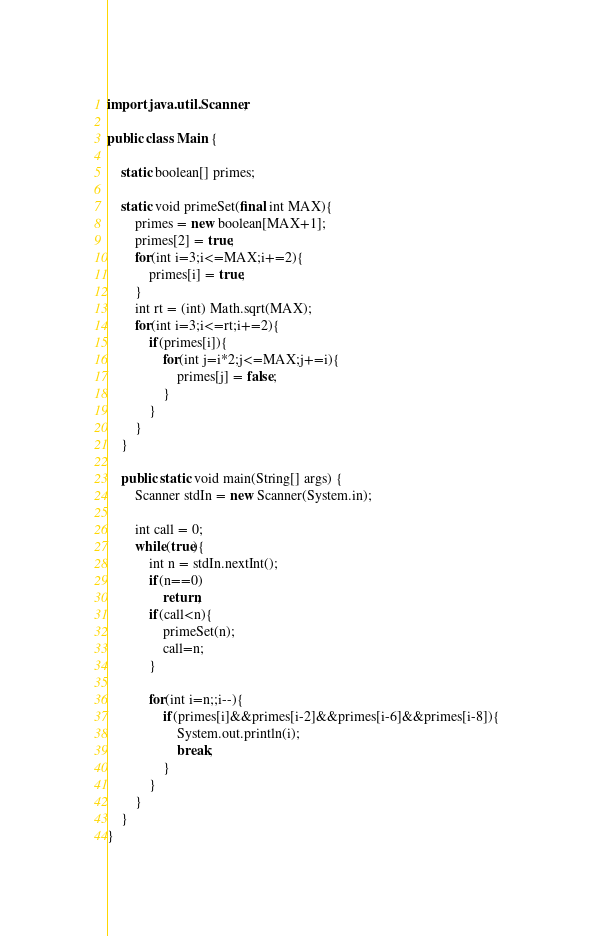<code> <loc_0><loc_0><loc_500><loc_500><_Java_>import java.util.Scanner;

public class Main {

	static boolean[] primes;

	static void primeSet(final int MAX){
		primes = new boolean[MAX+1];
		primes[2] = true;
		for(int i=3;i<=MAX;i+=2){
			primes[i] = true;
		}
		int rt = (int) Math.sqrt(MAX);
		for(int i=3;i<=rt;i+=2){
			if(primes[i]){
				for(int j=i*2;j<=MAX;j+=i){
					primes[j] = false;
				}
			}
		}
	}

	public static void main(String[] args) {
		Scanner stdIn = new Scanner(System.in);

		int call = 0;
		while(true){
			int n = stdIn.nextInt();
			if(n==0)
				return;
			if(call<n){
				primeSet(n);
				call=n;
			}

			for(int i=n;;i--){
				if(primes[i]&&primes[i-2]&&primes[i-6]&&primes[i-8]){
					System.out.println(i);
					break;
				}
			}
		}
	}
}</code> 